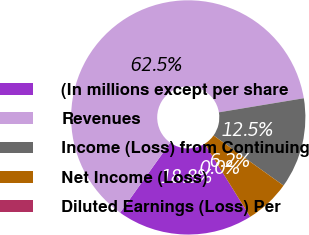Convert chart to OTSL. <chart><loc_0><loc_0><loc_500><loc_500><pie_chart><fcel>(In millions except per share<fcel>Revenues<fcel>Income (Loss) from Continuing<fcel>Net Income (Loss)<fcel>Diluted Earnings (Loss) Per<nl><fcel>18.75%<fcel>62.5%<fcel>12.5%<fcel>6.25%<fcel>0.0%<nl></chart> 